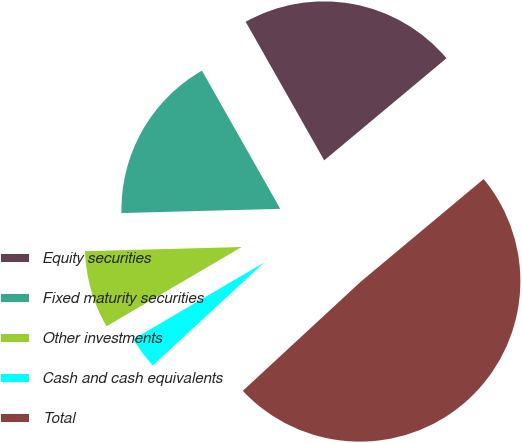Convert chart to OTSL. <chart><loc_0><loc_0><loc_500><loc_500><pie_chart><fcel>Equity securities<fcel>Fixed maturity securities<fcel>Other investments<fcel>Cash and cash equivalents<fcel>Total<nl><fcel>22.13%<fcel>17.22%<fcel>8.02%<fcel>3.44%<fcel>49.19%<nl></chart> 